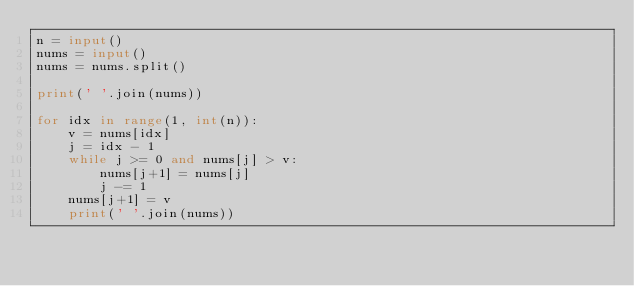Convert code to text. <code><loc_0><loc_0><loc_500><loc_500><_Python_>n = input()
nums = input()
nums = nums.split()

print(' '.join(nums))

for idx in range(1, int(n)):
    v = nums[idx]
    j = idx - 1
    while j >= 0 and nums[j] > v:
        nums[j+1] = nums[j]
        j -= 1
    nums[j+1] = v
    print(' '.join(nums))

</code> 